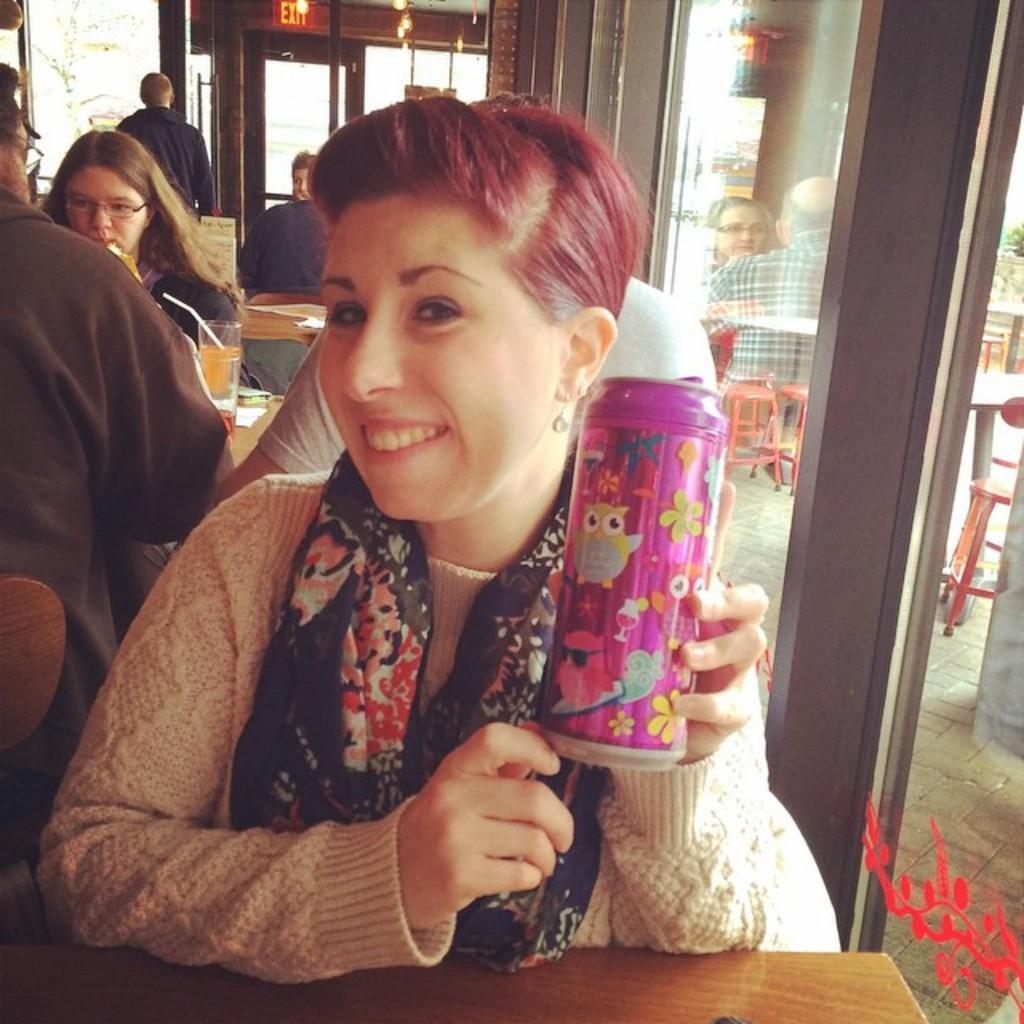What is the woman in the image doing? The woman is sitting in the image. What is the woman holding in the image? The woman is holding a bottle. What can be seen in the background of the image? There are other persons standing in the background, a wooden cupboard, and a tree visible in the background. What type of disease is the woman suffering from in the image? There is no indication in the image that the woman is suffering from any disease. 